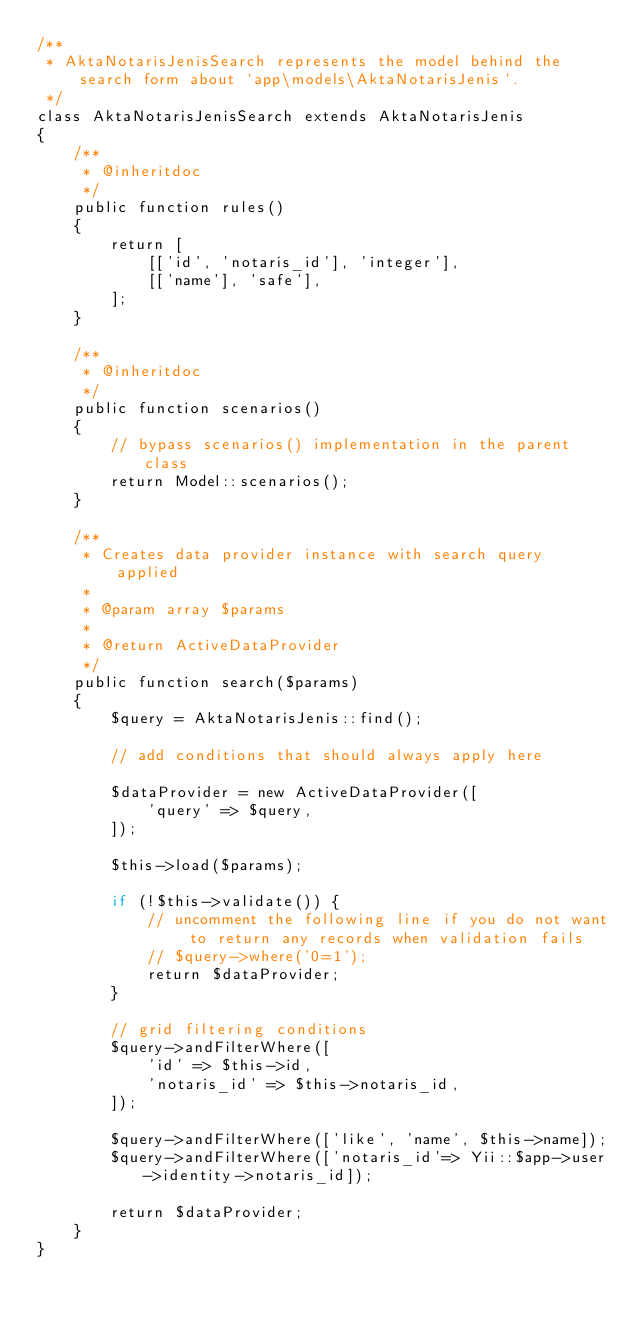<code> <loc_0><loc_0><loc_500><loc_500><_PHP_>/**
 * AktaNotarisJenisSearch represents the model behind the search form about `app\models\AktaNotarisJenis`.
 */
class AktaNotarisJenisSearch extends AktaNotarisJenis
{
    /**
     * @inheritdoc
     */
    public function rules()
    {
        return [
            [['id', 'notaris_id'], 'integer'],
            [['name'], 'safe'],
        ];
    }

    /**
     * @inheritdoc
     */
    public function scenarios()
    {
        // bypass scenarios() implementation in the parent class
        return Model::scenarios();
    }

    /**
     * Creates data provider instance with search query applied
     *
     * @param array $params
     *
     * @return ActiveDataProvider
     */
    public function search($params)
    {
        $query = AktaNotarisJenis::find();

        // add conditions that should always apply here

        $dataProvider = new ActiveDataProvider([
            'query' => $query,
        ]);

        $this->load($params);

        if (!$this->validate()) {
            // uncomment the following line if you do not want to return any records when validation fails
            // $query->where('0=1');
            return $dataProvider;
        }

        // grid filtering conditions
        $query->andFilterWhere([
            'id' => $this->id,
            'notaris_id' => $this->notaris_id,
        ]);

        $query->andFilterWhere(['like', 'name', $this->name]);
        $query->andFilterWhere(['notaris_id'=> Yii::$app->user->identity->notaris_id]);

        return $dataProvider;
    }
}
</code> 